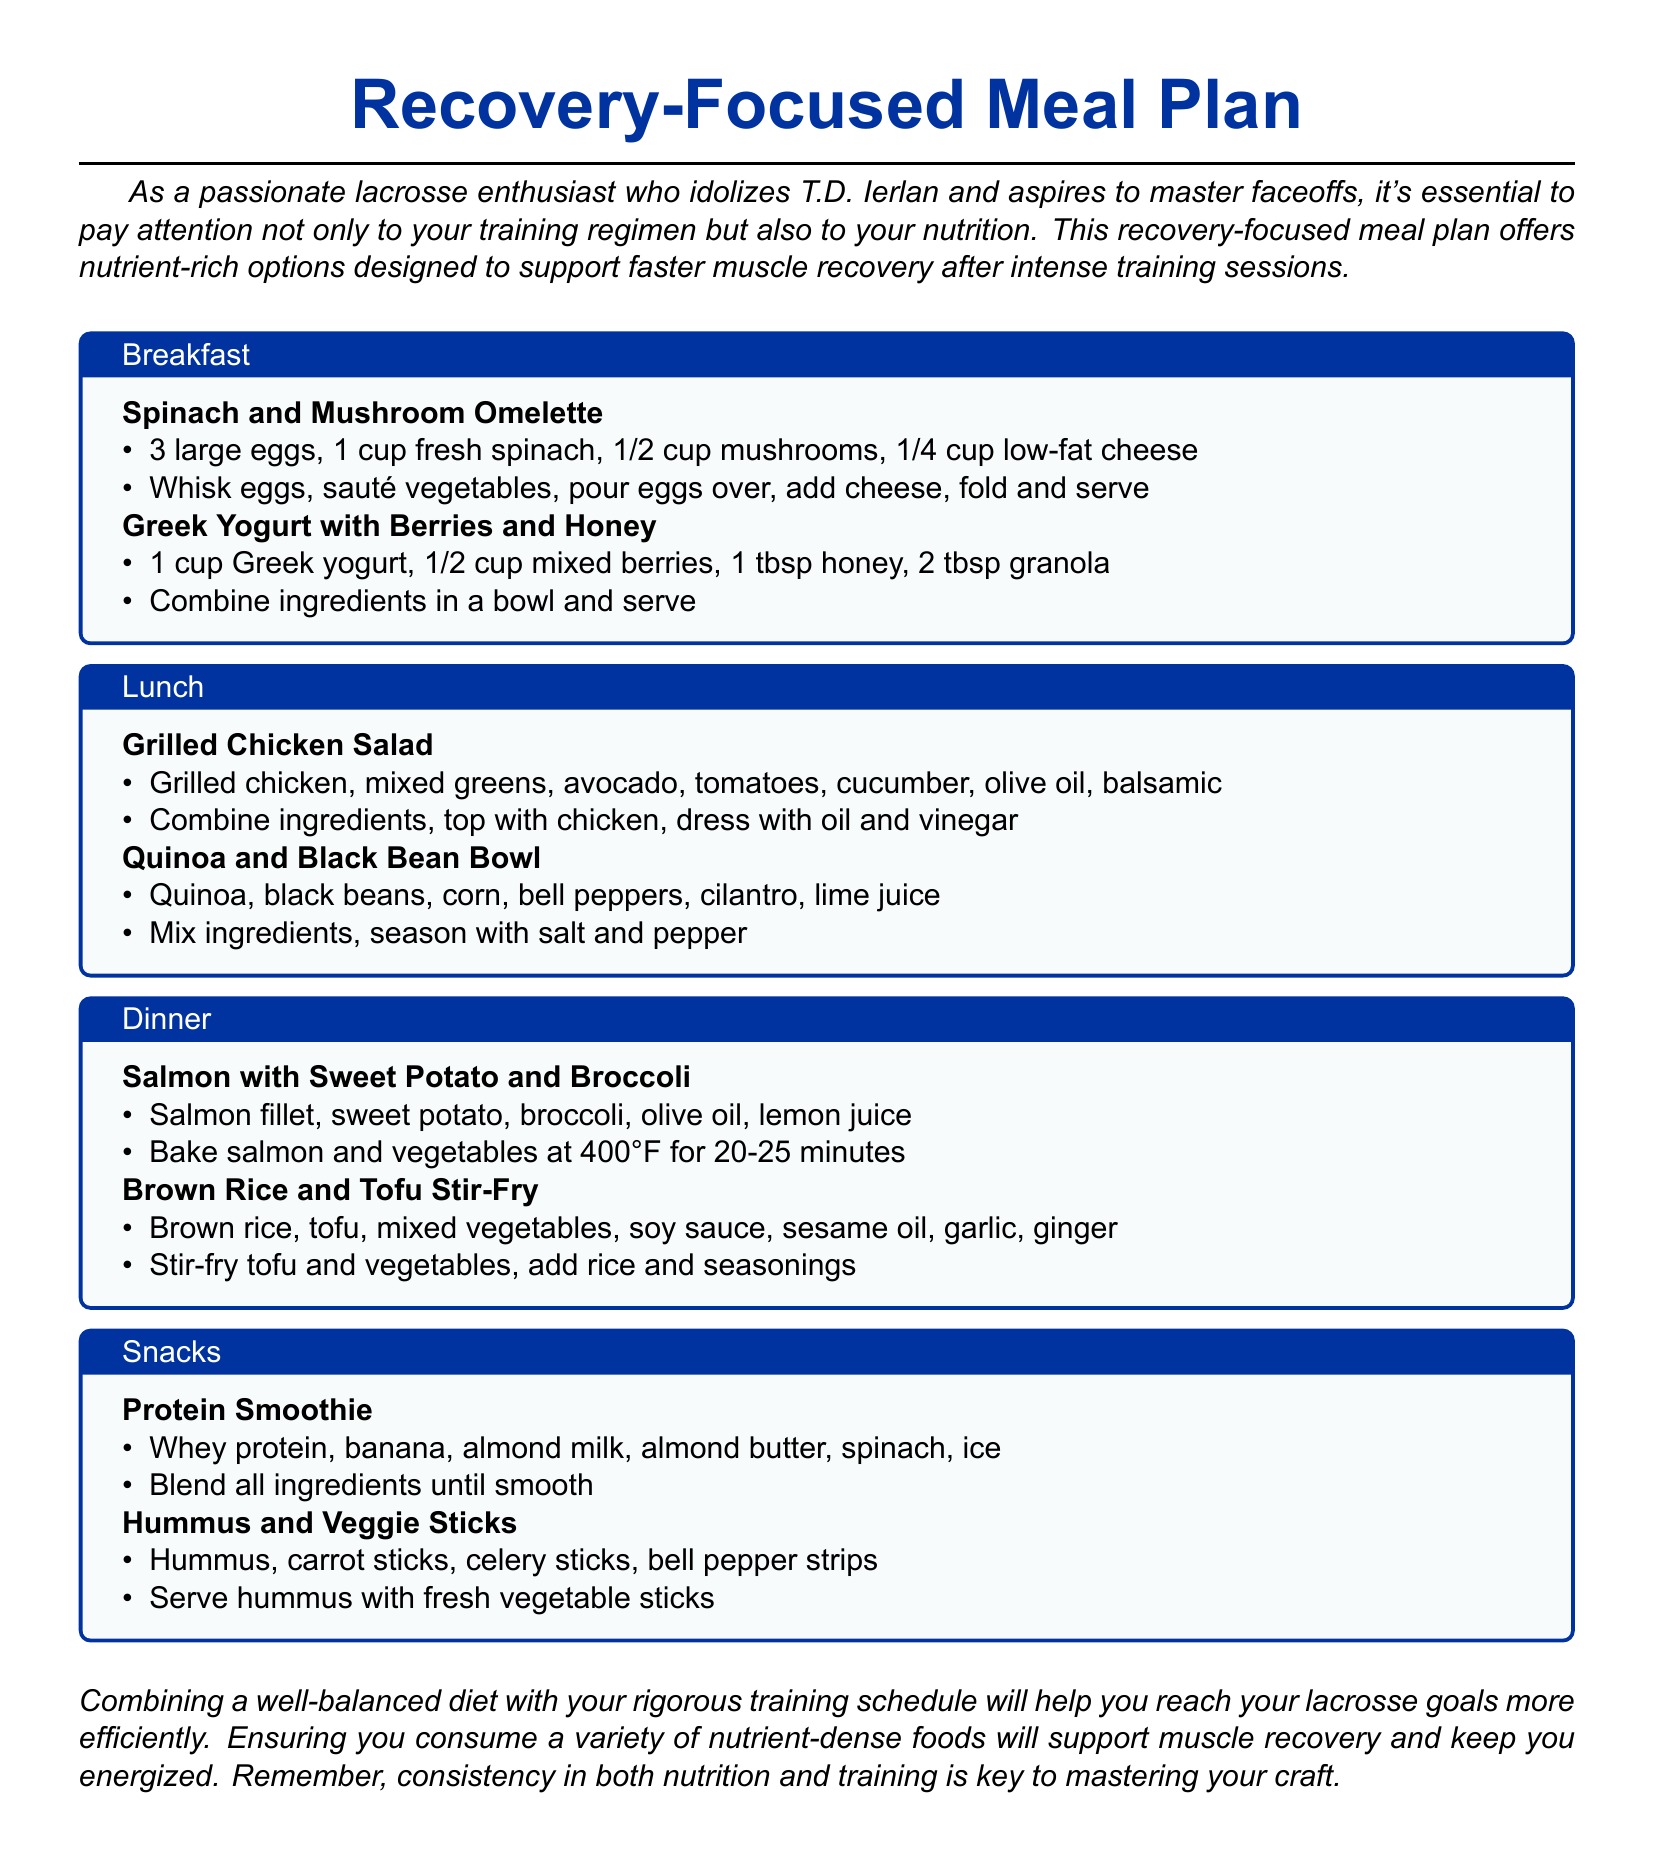What is the title of the meal plan? The title of the meal plan is located at the top of the document.
Answer: Recovery-Focused Meal Plan How many eggs are used in the spinach and mushroom omelette? The number of eggs is listed in the ingredients for the omelette.
Answer: 3 large eggs What type of salad is mentioned in the lunch section? The type of salad can be found in the lunch section of the meal plan.
Answer: Grilled Chicken Salad What main protein is included in the dinner option for salmon? The main protein source in the dinner option is specified in the ingredients for that meal.
Answer: Salmon fillet What is a key ingredient in the protein smoothie? The key ingredient can be seen in the snack section's recipe for the protein smoothie.
Answer: Whey protein What meal component is used in the quinoa and black bean bowl? The meal component is detailed in the lunch section of the meal plan.
Answer: Quinoa What vegetable is paired with the salmon in dinner? The vegetable option can be found listed with the salmon dish in the dinner section.
Answer: Broccoli How is the brown rice and tofu stir-fry prepared? The preparation method is explained in the dinner section under the stir-fry recipe.
Answer: Stir-fry tofu and vegetables What type of oil is used in the grilled chicken salad dressing? The type of oil used in the dressing is mentioned in the ingredients of the salad.
Answer: Olive oil 